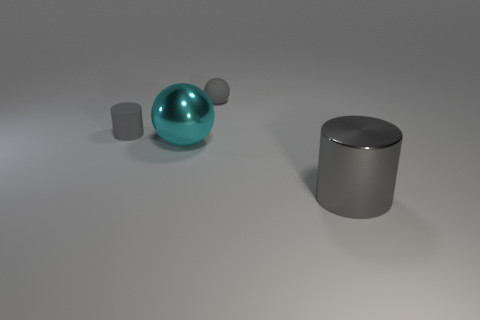Add 1 small gray matte objects. How many objects exist? 5 Add 4 tiny gray balls. How many tiny gray balls are left? 5 Add 4 tiny rubber objects. How many tiny rubber objects exist? 6 Subtract 0 yellow cylinders. How many objects are left? 4 Subtract all cylinders. Subtract all big yellow objects. How many objects are left? 2 